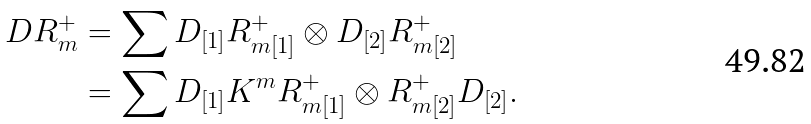<formula> <loc_0><loc_0><loc_500><loc_500>D R ^ { + } _ { m } & = \sum D _ { [ 1 ] } R ^ { + } _ { m [ 1 ] } \otimes D _ { [ 2 ] } R ^ { + } _ { m [ 2 ] } \\ & = \sum D _ { [ 1 ] } K ^ { m } R ^ { + } _ { m [ 1 ] } \otimes R ^ { + } _ { m [ 2 ] } D _ { [ 2 ] } .</formula> 